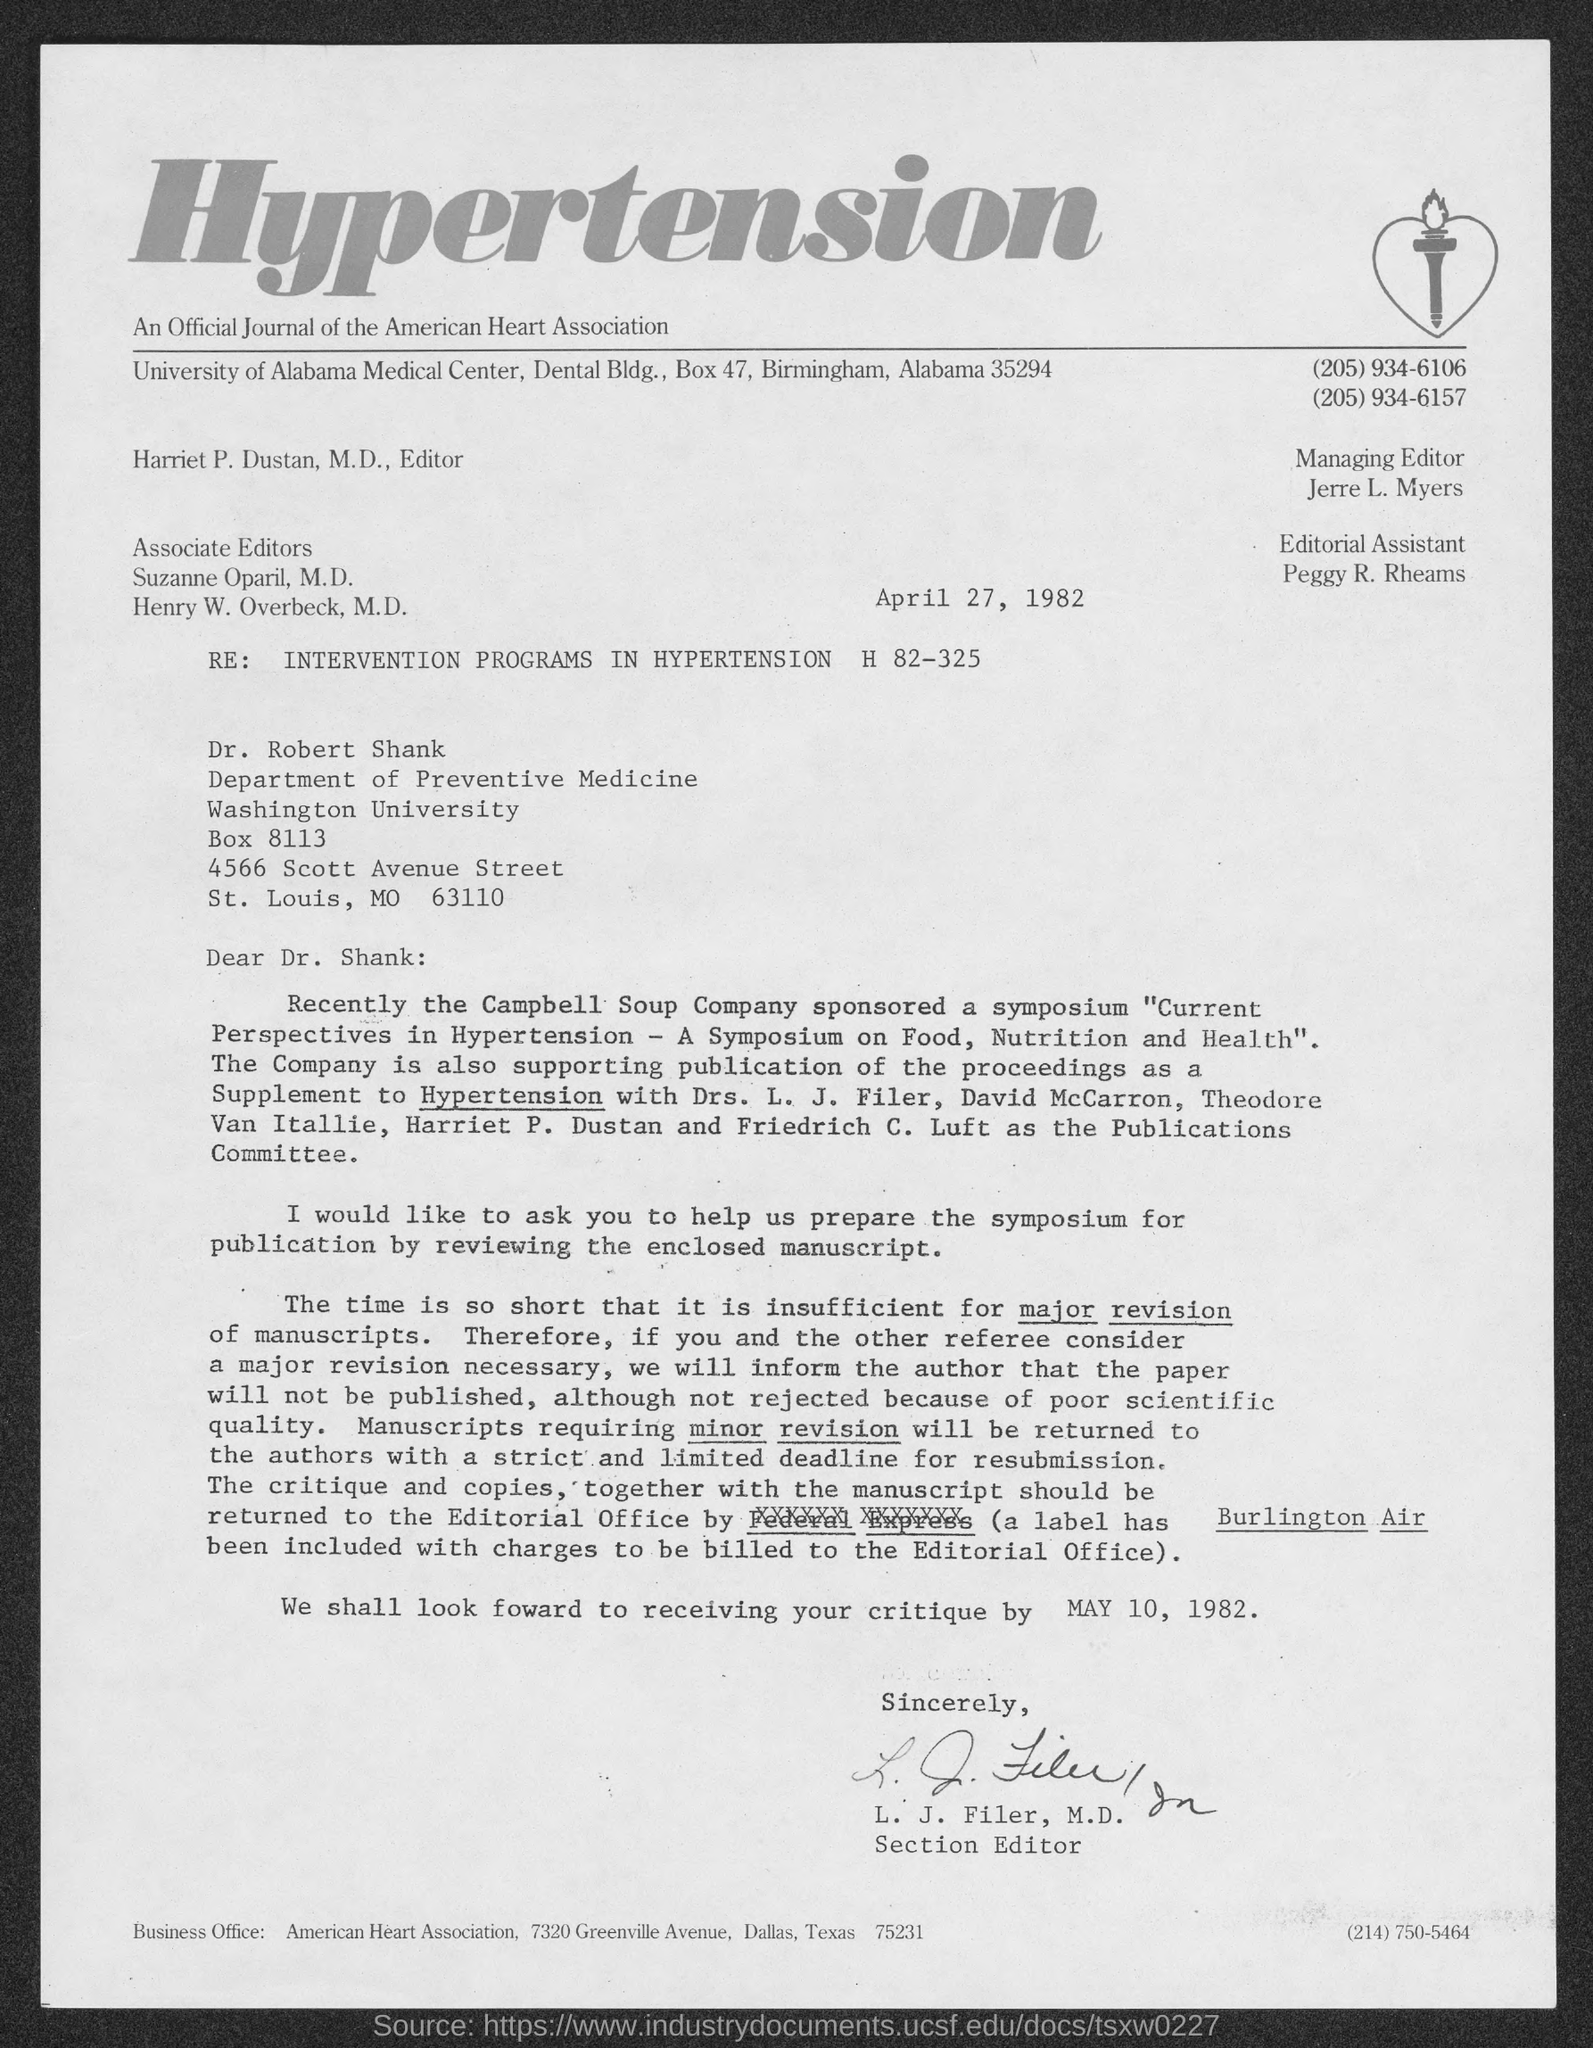In which city is university of alabama medical center at ?
Your response must be concise. Birmingham. What is the position of l.j. filer, m.d.?
Your answer should be very brief. Section editor. What is the position of harriet p. dustan, m.d.?
Give a very brief answer. Editor. What is the position of jerre l. myers?
Give a very brief answer. Managing editor. What is the position of peggy r. rheams ?
Provide a succinct answer. Editorial assistant. In which city is american heart association at?
Your answer should be compact. Dallas. 